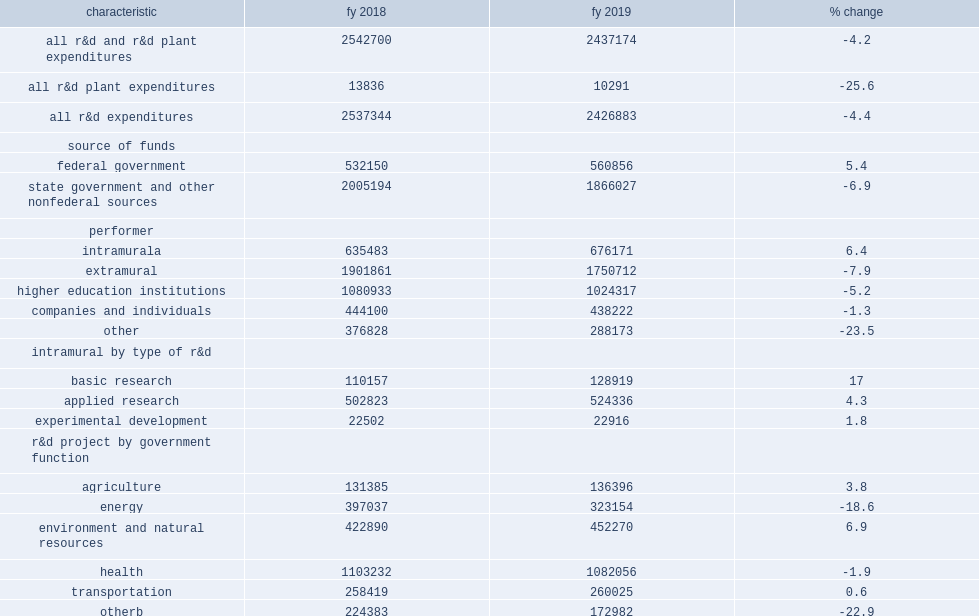How many thousand dollars did state government agency expenditures for research and development total in fy 2019? 2437174.0. How many thousand dollars did state government agency expenditures for research and development total in fy 2018? 2542700.0. 